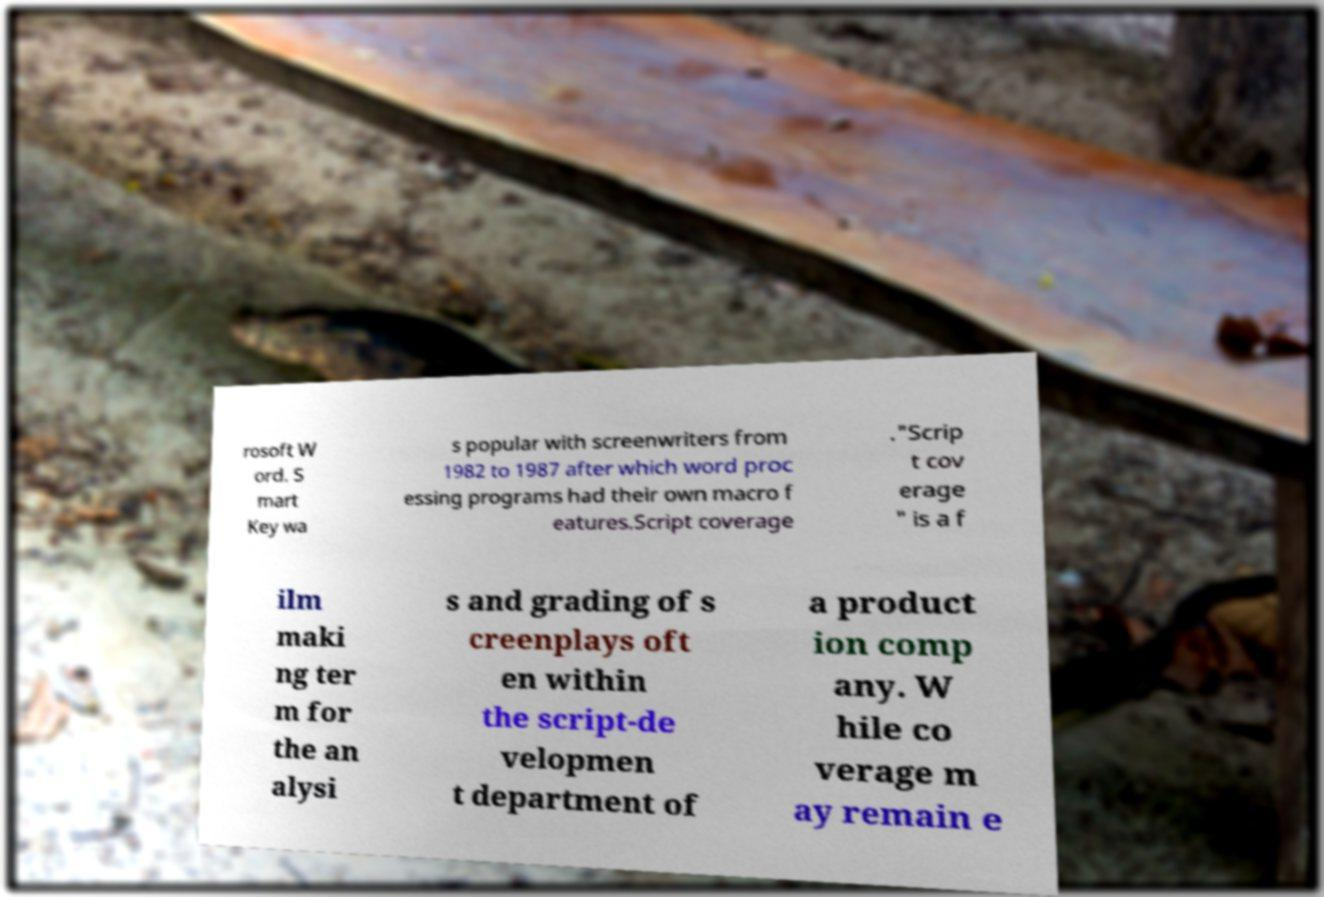Please identify and transcribe the text found in this image. rosoft W ord. S mart Key wa s popular with screenwriters from 1982 to 1987 after which word proc essing programs had their own macro f eatures.Script coverage ."Scrip t cov erage " is a f ilm maki ng ter m for the an alysi s and grading of s creenplays oft en within the script-de velopmen t department of a product ion comp any. W hile co verage m ay remain e 